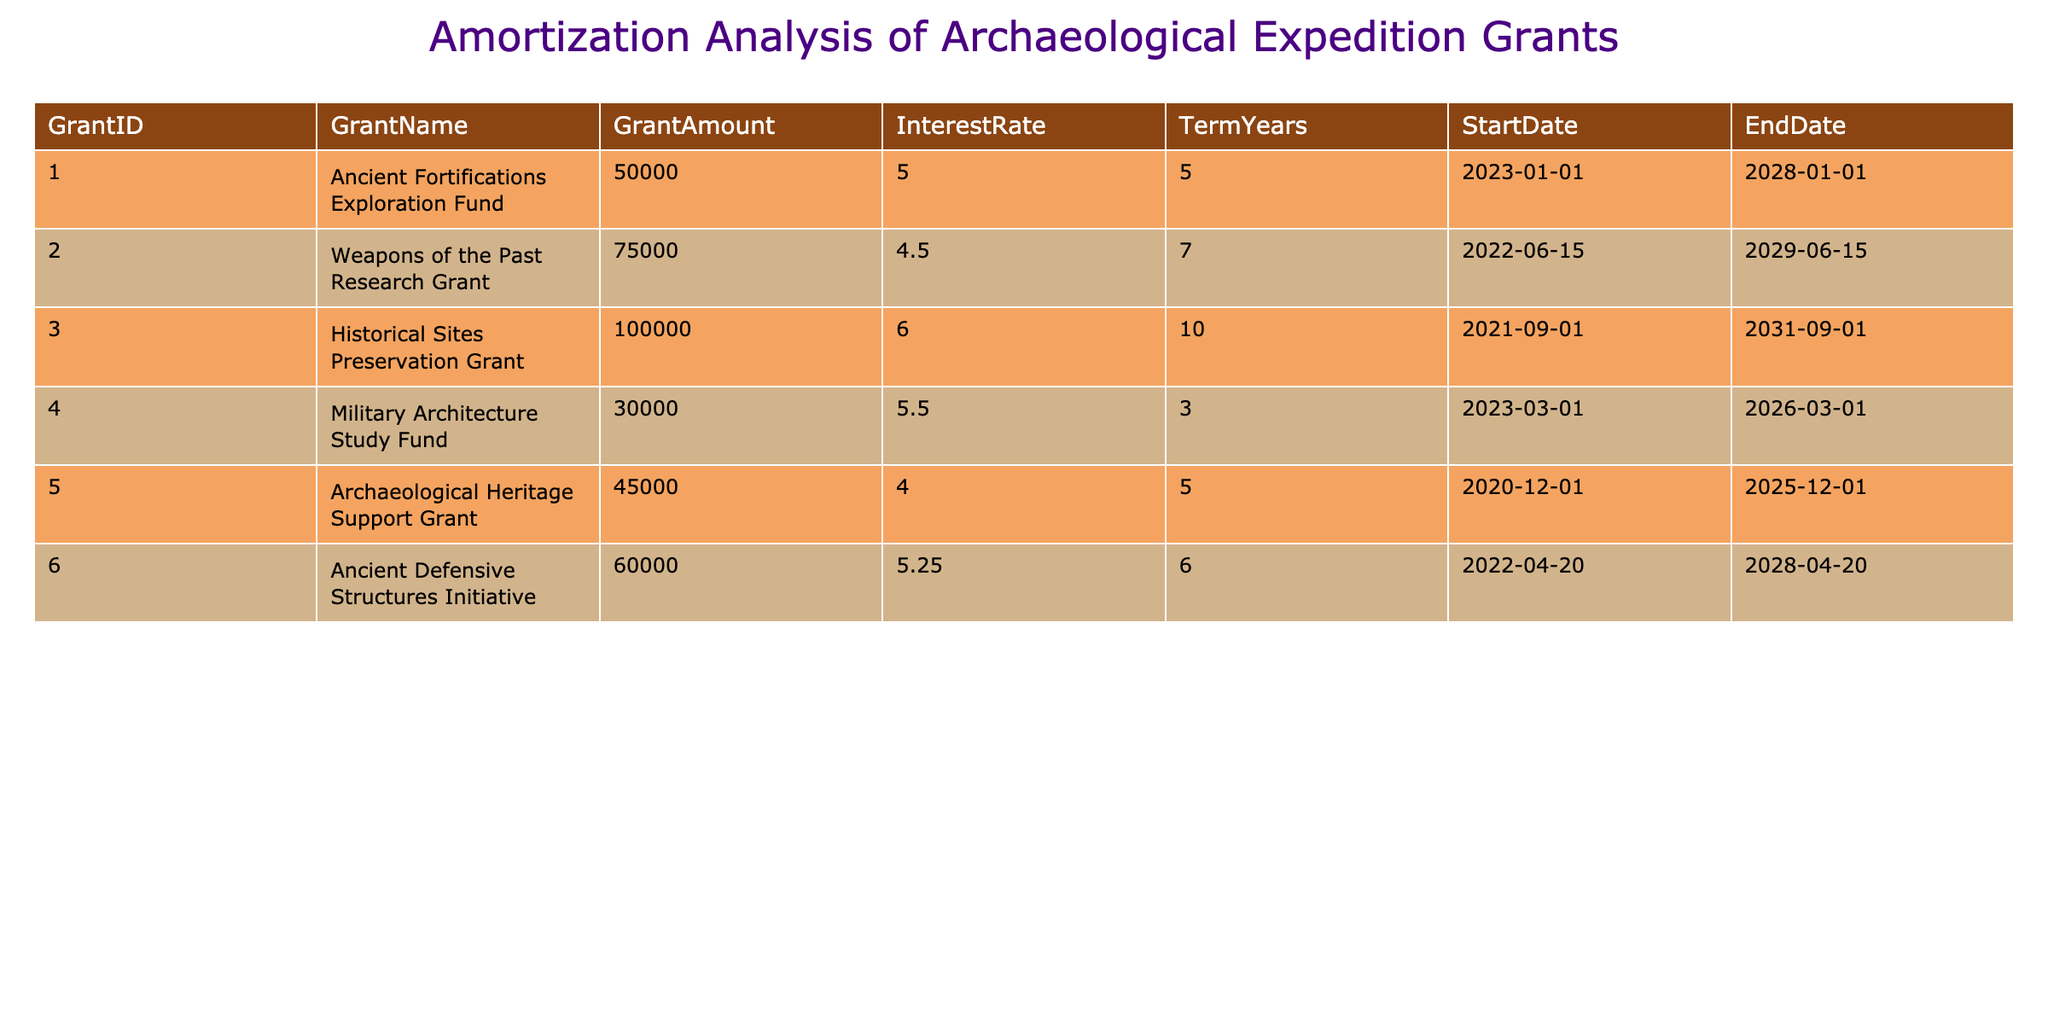What is the total amount of grants received for military architecture studies? There is one grant listed for military architecture studies, which is the Military Architecture Study Fund with a grant amount of 30000.
Answer: 30000 Which grant has the highest interest rate? Looking through the interest rates in the table, the Historical Sites Preservation Grant has the highest rate at 6.0.
Answer: 6.0 How many grants were awarded for a term longer than 5 years? The grants with terms longer than 5 years are the Historical Sites Preservation Grant (10 years) and the Weapons of the Past Research Grant (7 years), making a total of 2.
Answer: 2 What is the average grant amount for all the mentioned grants? To find the average grant amount, sum the amounts (50000 + 75000 + 100000 + 30000 + 45000 + 60000 = 325000) and divide by the total number of grants (6), which gives 325000 / 6 = 54166.67.
Answer: 54166.67 Is it true that all grants have a term of at least 3 years? Checking the terms in the table, the shortest term is 3 years for the Military Architecture Study Fund, while the other grants have terms of 5, 6, and 10 years, confirming the statement is true.
Answer: True What is the difference in grant amounts between the highest and lowest grants? The highest grant amount is 100000 from the Historical Sites Preservation Grant, and the lowest is 30000 from the Military Architecture Study Fund. The difference is 100000 - 30000 = 70000.
Answer: 70000 If a new grant with an amount of 55000 were added with a term of 5 years at an interest rate of 4.5%, what would be the average interest rate of all grants? Currently, the total interest rates are 5, 4.5, 6, 5.5, 4, and 5.25 (total = 30.25). Adding the new grant at 4.5 gives a total of 30.25 + 4.5 = 34.75. With 7 grants now, the average interest rate is 34.75 / 7 = 4.96.
Answer: 4.96 Which grant was received earliest, and what is its end date? The earliest start date is for the Archaeological Heritage Support Grant on 2020-12-01, and its end date is 2025-12-01.
Answer: 2025-12-01 How many grants were received in 2023? The list includes two grants that started in 2023: the Ancient Fortifications Exploration Fund and the Military Architecture Study Fund. Therefore, the total is 2.
Answer: 2 